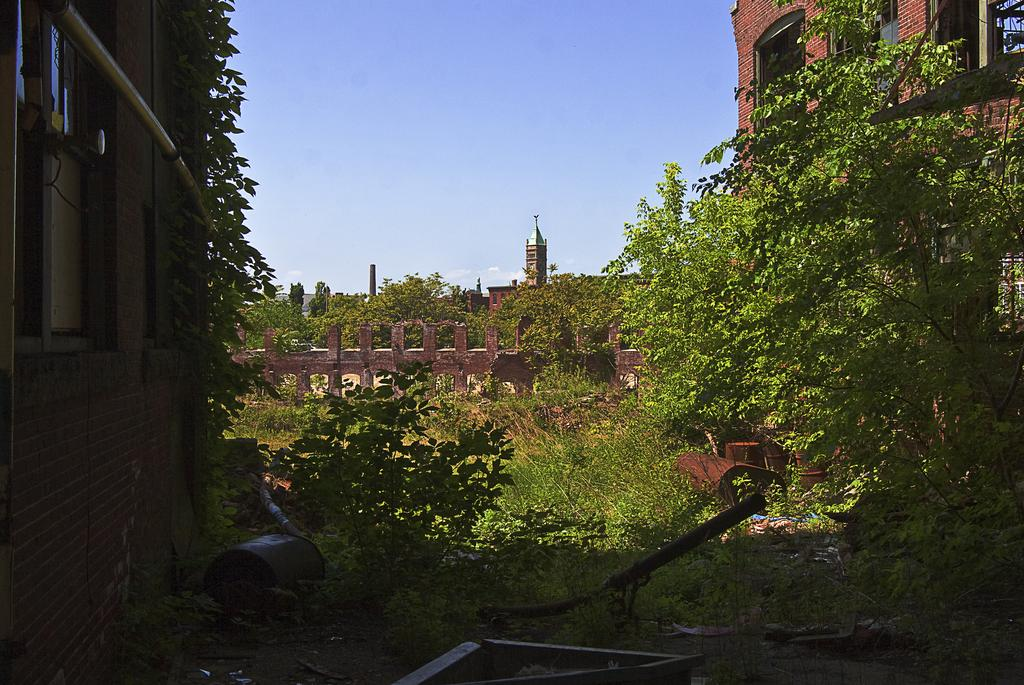What type of structure is visible in the image? There is a building in the image. What can be seen attached to the building? There is a pipe in the image. What type of plant is present in the image? There is a tree in the image. What feature of the building is visible in the image? There is a window in the image. What objects are on the ground in the image? There are objects on the ground in the image. What can be seen in the background of the image? There are buildings, trees, and the sky visible in the background of the image. Can you tell me how many yams are growing near the tree in the image? There are no yams present in the image; it features a building, a pipe, a tree, a window, objects on the ground, and a background with buildings, trees, and the sky. What type of cactus can be seen in the image? There is no cactus present in the image. 